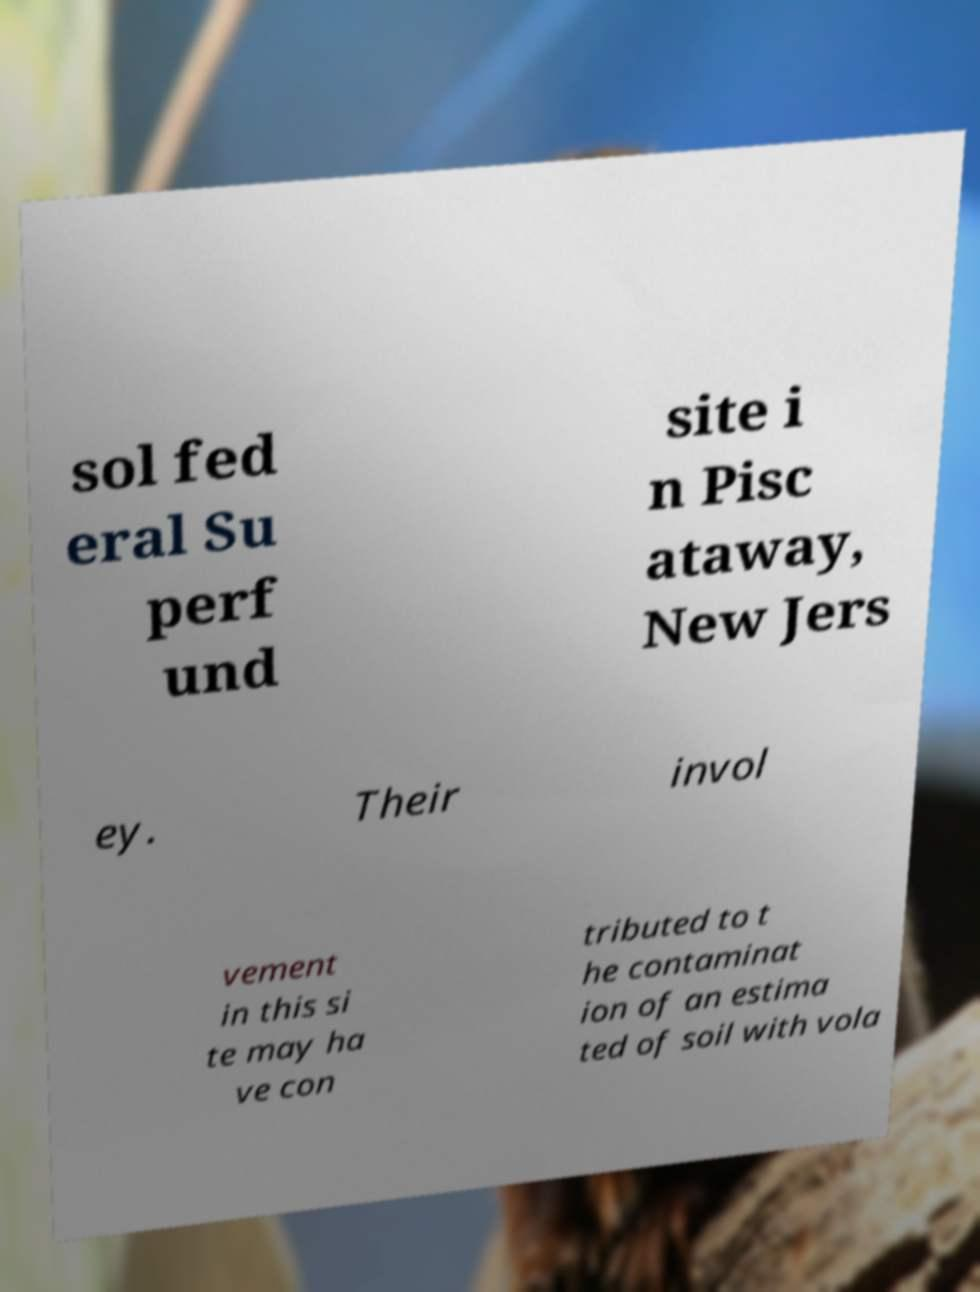Could you extract and type out the text from this image? sol fed eral Su perf und site i n Pisc ataway, New Jers ey. Their invol vement in this si te may ha ve con tributed to t he contaminat ion of an estima ted of soil with vola 